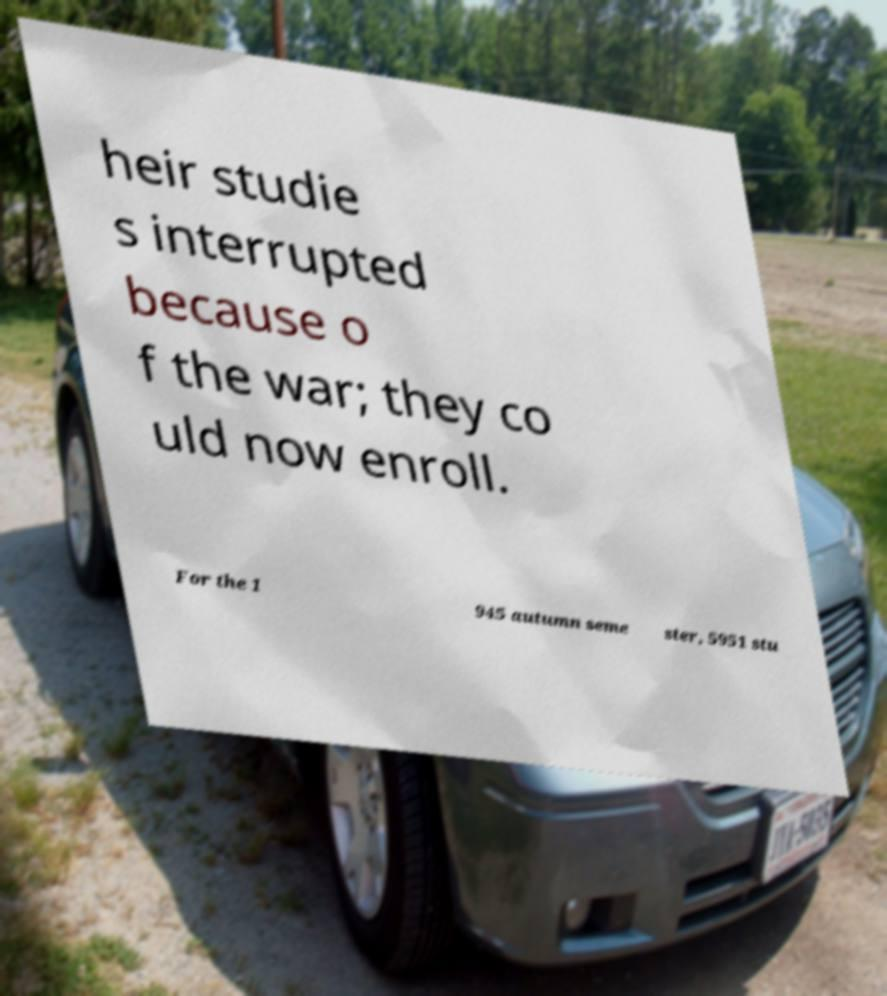Can you read and provide the text displayed in the image?This photo seems to have some interesting text. Can you extract and type it out for me? heir studie s interrupted because o f the war; they co uld now enroll. For the 1 945 autumn seme ster, 5951 stu 